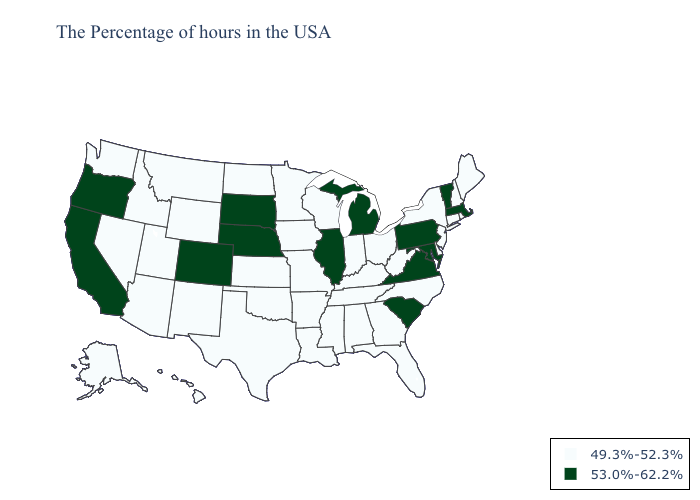Is the legend a continuous bar?
Quick response, please. No. Name the states that have a value in the range 49.3%-52.3%?
Be succinct. Maine, Rhode Island, New Hampshire, Connecticut, New York, New Jersey, Delaware, North Carolina, West Virginia, Ohio, Florida, Georgia, Kentucky, Indiana, Alabama, Tennessee, Wisconsin, Mississippi, Louisiana, Missouri, Arkansas, Minnesota, Iowa, Kansas, Oklahoma, Texas, North Dakota, Wyoming, New Mexico, Utah, Montana, Arizona, Idaho, Nevada, Washington, Alaska, Hawaii. Name the states that have a value in the range 53.0%-62.2%?
Concise answer only. Massachusetts, Vermont, Maryland, Pennsylvania, Virginia, South Carolina, Michigan, Illinois, Nebraska, South Dakota, Colorado, California, Oregon. What is the lowest value in the Northeast?
Be succinct. 49.3%-52.3%. Does Kentucky have the lowest value in the South?
Give a very brief answer. Yes. Name the states that have a value in the range 49.3%-52.3%?
Give a very brief answer. Maine, Rhode Island, New Hampshire, Connecticut, New York, New Jersey, Delaware, North Carolina, West Virginia, Ohio, Florida, Georgia, Kentucky, Indiana, Alabama, Tennessee, Wisconsin, Mississippi, Louisiana, Missouri, Arkansas, Minnesota, Iowa, Kansas, Oklahoma, Texas, North Dakota, Wyoming, New Mexico, Utah, Montana, Arizona, Idaho, Nevada, Washington, Alaska, Hawaii. Among the states that border Georgia , which have the lowest value?
Short answer required. North Carolina, Florida, Alabama, Tennessee. How many symbols are there in the legend?
Be succinct. 2. What is the highest value in the Northeast ?
Write a very short answer. 53.0%-62.2%. How many symbols are there in the legend?
Answer briefly. 2. What is the value of Alaska?
Be succinct. 49.3%-52.3%. Does Michigan have the lowest value in the USA?
Be succinct. No. What is the highest value in the MidWest ?
Concise answer only. 53.0%-62.2%. Name the states that have a value in the range 49.3%-52.3%?
Answer briefly. Maine, Rhode Island, New Hampshire, Connecticut, New York, New Jersey, Delaware, North Carolina, West Virginia, Ohio, Florida, Georgia, Kentucky, Indiana, Alabama, Tennessee, Wisconsin, Mississippi, Louisiana, Missouri, Arkansas, Minnesota, Iowa, Kansas, Oklahoma, Texas, North Dakota, Wyoming, New Mexico, Utah, Montana, Arizona, Idaho, Nevada, Washington, Alaska, Hawaii. Among the states that border Connecticut , does Rhode Island have the lowest value?
Short answer required. Yes. 